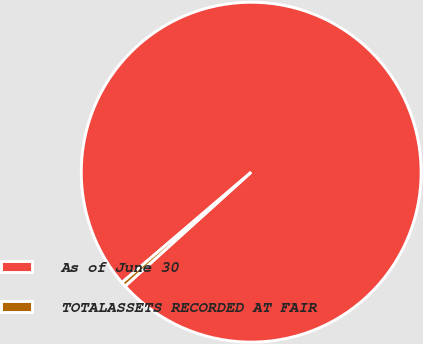Convert chart. <chart><loc_0><loc_0><loc_500><loc_500><pie_chart><fcel>As of June 30<fcel>TOTALASSETS RECORDED AT FAIR<nl><fcel>99.55%<fcel>0.45%<nl></chart> 